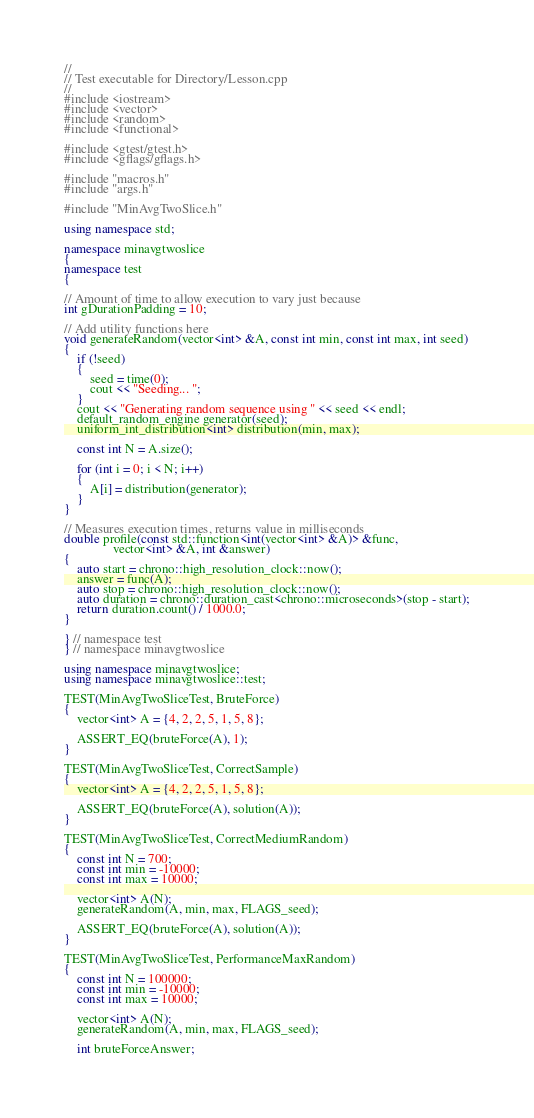<code> <loc_0><loc_0><loc_500><loc_500><_C++_>//
// Test executable for Directory/Lesson.cpp
//
#include <iostream>
#include <vector>
#include <random>
#include <functional>

#include <gtest/gtest.h>
#include <gflags/gflags.h>

#include "macros.h"
#include "args.h"

#include "MinAvgTwoSlice.h"

using namespace std;

namespace minavgtwoslice
{
namespace test
{

// Amount of time to allow execution to vary just because
int gDurationPadding = 10;

// Add utility functions here
void generateRandom(vector<int> &A, const int min, const int max, int seed)
{
    if (!seed)
    {
        seed = time(0);
        cout << "Seeding... ";
    }
    cout << "Generating random sequence using " << seed << endl;
    default_random_engine generator(seed);
    uniform_int_distribution<int> distribution(min, max);

    const int N = A.size();

    for (int i = 0; i < N; i++)
    {
        A[i] = distribution(generator);
    }
}

// Measures execution times, returns value in milliseconds
double profile(const std::function<int(vector<int> &A)> &func,
               vector<int> &A, int &answer)
{
    auto start = chrono::high_resolution_clock::now();
    answer = func(A);
    auto stop = chrono::high_resolution_clock::now();
    auto duration = chrono::duration_cast<chrono::microseconds>(stop - start);
    return duration.count() / 1000.0;
}

} // namespace test
} // namespace minavgtwoslice

using namespace minavgtwoslice;
using namespace minavgtwoslice::test;

TEST(MinAvgTwoSliceTest, BruteForce)
{
    vector<int> A = {4, 2, 2, 5, 1, 5, 8};

    ASSERT_EQ(bruteForce(A), 1);
}

TEST(MinAvgTwoSliceTest, CorrectSample)
{
    vector<int> A = {4, 2, 2, 5, 1, 5, 8};

    ASSERT_EQ(bruteForce(A), solution(A));
}

TEST(MinAvgTwoSliceTest, CorrectMediumRandom)
{
    const int N = 700;
    const int min = -10000;
    const int max = 10000;

    vector<int> A(N);
    generateRandom(A, min, max, FLAGS_seed);

    ASSERT_EQ(bruteForce(A), solution(A));
}

TEST(MinAvgTwoSliceTest, PerformanceMaxRandom)
{
    const int N = 100000;
    const int min = -10000;
    const int max = 10000;

    vector<int> A(N);
    generateRandom(A, min, max, FLAGS_seed);

    int bruteForceAnswer;</code> 